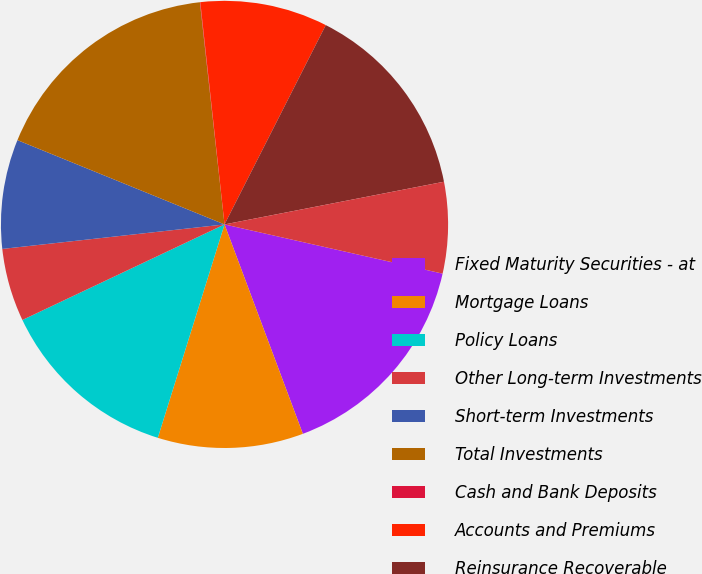<chart> <loc_0><loc_0><loc_500><loc_500><pie_chart><fcel>Fixed Maturity Securities - at<fcel>Mortgage Loans<fcel>Policy Loans<fcel>Other Long-term Investments<fcel>Short-term Investments<fcel>Total Investments<fcel>Cash and Bank Deposits<fcel>Accounts and Premiums<fcel>Reinsurance Recoverable<fcel>Accrued Investment Income<nl><fcel>15.77%<fcel>10.52%<fcel>13.15%<fcel>5.28%<fcel>7.9%<fcel>17.09%<fcel>0.03%<fcel>9.21%<fcel>14.46%<fcel>6.59%<nl></chart> 